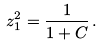<formula> <loc_0><loc_0><loc_500><loc_500>z _ { 1 } ^ { 2 } = \frac { 1 } { 1 + C } \, .</formula> 